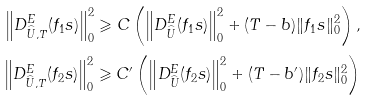<formula> <loc_0><loc_0><loc_500><loc_500>\left \| D _ { \widehat { U } , T } ^ { E } ( f _ { 1 } s ) \right \| ^ { 2 } _ { 0 } \geqslant C \left ( \left \| D _ { \widehat { U } } ^ { E } ( f _ { 1 } s ) \right \| ^ { 2 } _ { 0 } + ( T - b ) \| f _ { 1 } s \| ^ { 2 } _ { 0 } \right ) , \\ \left \| D _ { \widehat { U } , T } ^ { E } ( f _ { 2 } s ) \right \| ^ { 2 } _ { 0 } \geqslant C ^ { \prime } \left ( \left \| D _ { \widehat { U } } ^ { E } ( f _ { 2 } s ) \right \| ^ { 2 } _ { 0 } + ( T - b ^ { \prime } ) \| f _ { 2 } s \| ^ { 2 } _ { 0 } \right )</formula> 